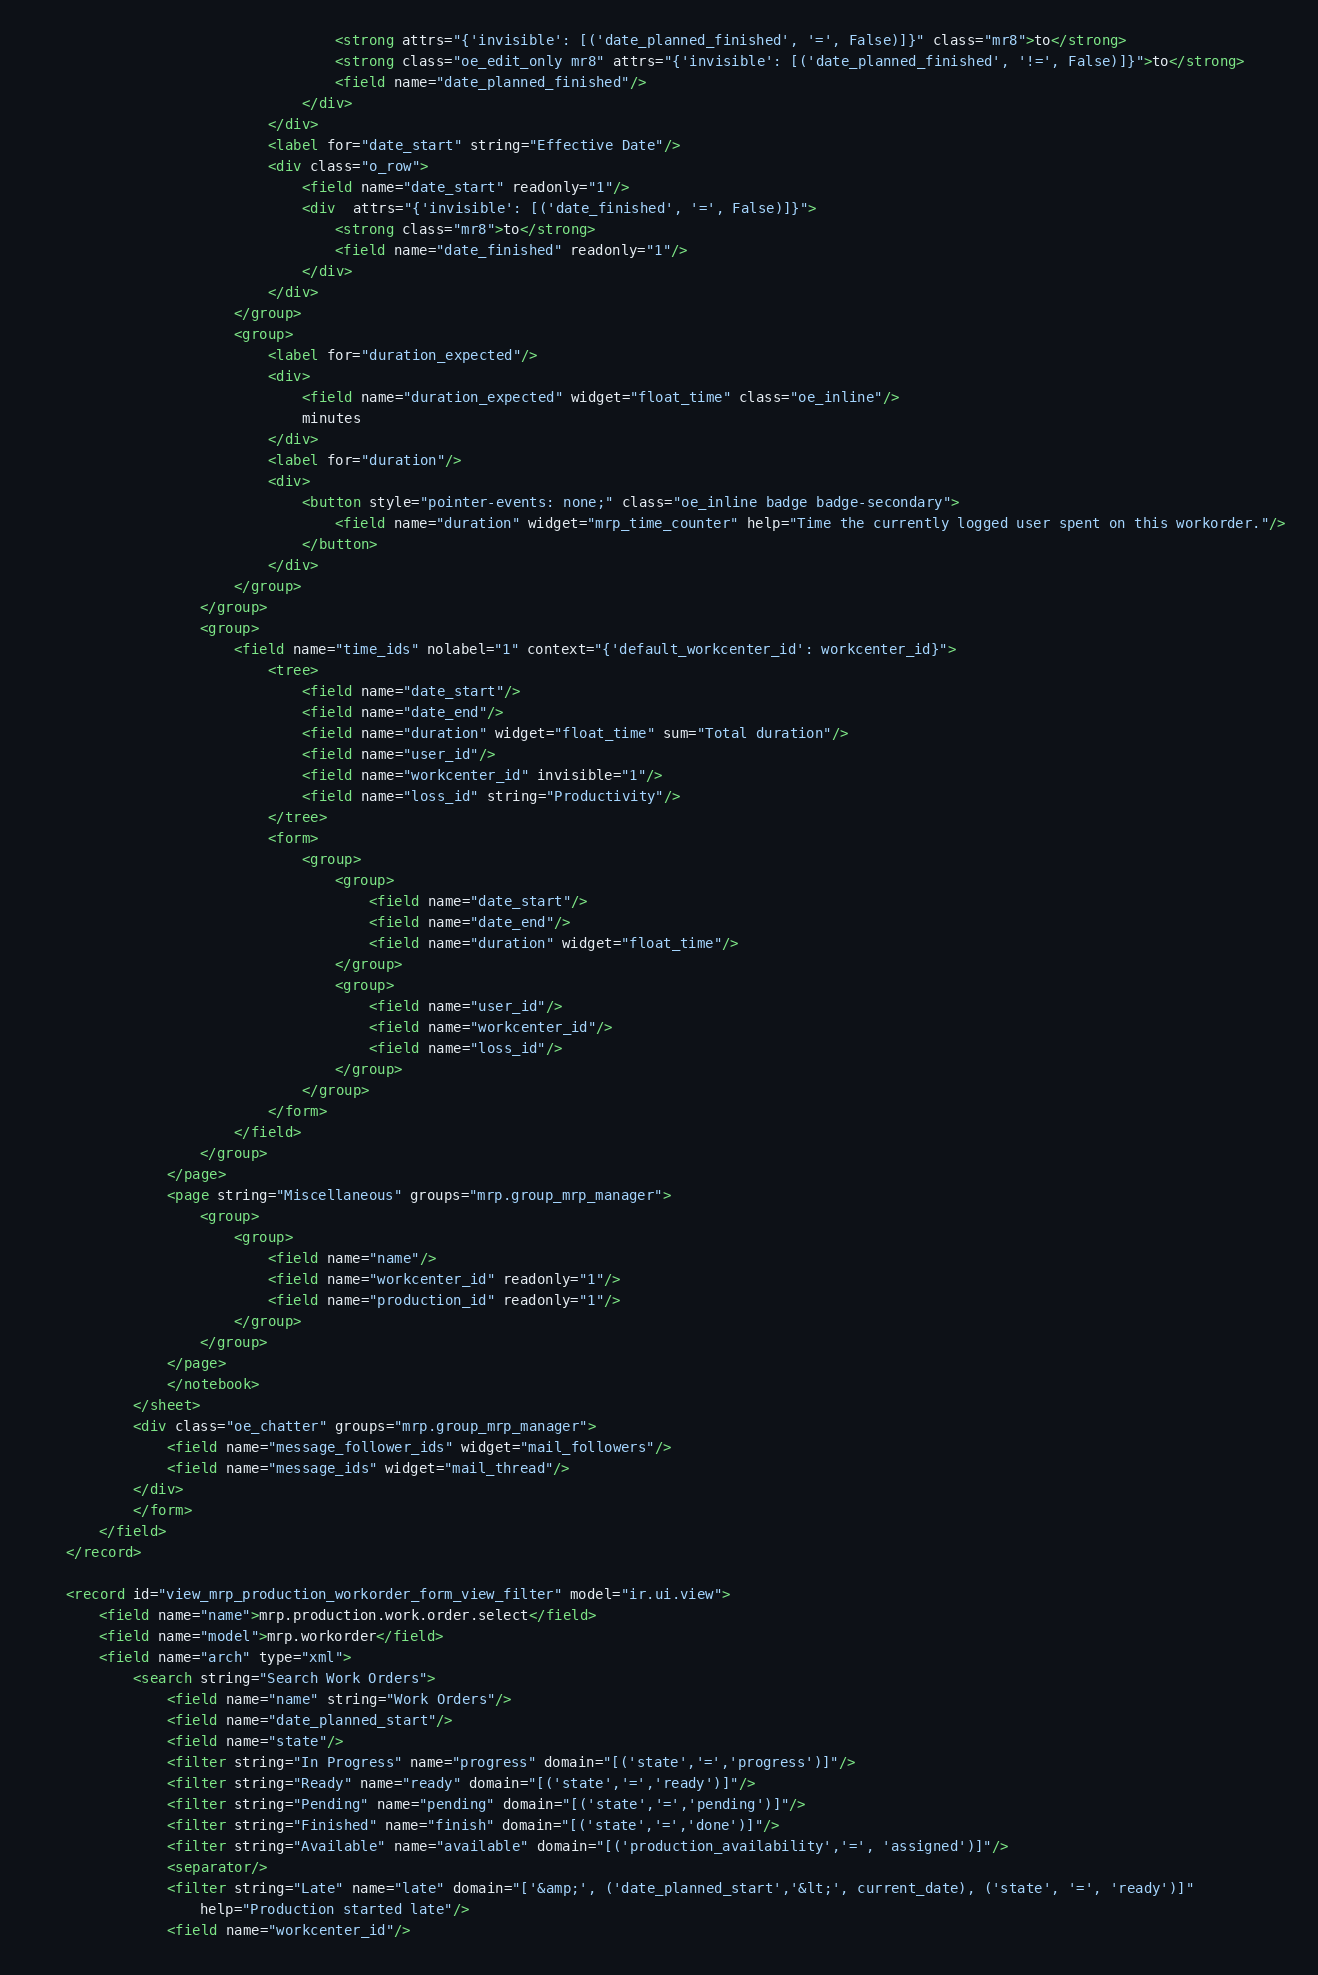<code> <loc_0><loc_0><loc_500><loc_500><_XML_>                                    <strong attrs="{'invisible': [('date_planned_finished', '=', False)]}" class="mr8">to</strong>
                                    <strong class="oe_edit_only mr8" attrs="{'invisible': [('date_planned_finished', '!=', False)]}">to</strong>
                                    <field name="date_planned_finished"/>
                                </div>
                            </div>
                            <label for="date_start" string="Effective Date"/>
                            <div class="o_row">
                                <field name="date_start" readonly="1"/>
                                <div  attrs="{'invisible': [('date_finished', '=', False)]}">
                                    <strong class="mr8">to</strong>
                                    <field name="date_finished" readonly="1"/>
                                </div>
                            </div>
                        </group>
                        <group>
                            <label for="duration_expected"/>
                            <div>
                                <field name="duration_expected" widget="float_time" class="oe_inline"/>
                                minutes
                            </div>
                            <label for="duration"/>
                            <div>
                                <button style="pointer-events: none;" class="oe_inline badge badge-secondary">
                                    <field name="duration" widget="mrp_time_counter" help="Time the currently logged user spent on this workorder."/>
                                </button>
                            </div>
                        </group>
                    </group>
                    <group>
                        <field name="time_ids" nolabel="1" context="{'default_workcenter_id': workcenter_id}">
                            <tree>
                                <field name="date_start"/>
                                <field name="date_end"/>
                                <field name="duration" widget="float_time" sum="Total duration"/>
                                <field name="user_id"/>
                                <field name="workcenter_id" invisible="1"/>
                                <field name="loss_id" string="Productivity"/>
                            </tree>
                            <form>
                                <group>
                                    <group>
                                        <field name="date_start"/>
                                        <field name="date_end"/>
                                        <field name="duration" widget="float_time"/>
                                    </group>
                                    <group>
                                        <field name="user_id"/>
                                        <field name="workcenter_id"/>
                                        <field name="loss_id"/>
                                    </group>
                                </group>
                            </form>
                        </field>
                    </group>
                </page>
                <page string="Miscellaneous" groups="mrp.group_mrp_manager">
                    <group>
                        <group>
                            <field name="name"/>
                            <field name="workcenter_id" readonly="1"/>
                            <field name="production_id" readonly="1"/>
                        </group>
                    </group>
                </page>
                </notebook>
            </sheet>
            <div class="oe_chatter" groups="mrp.group_mrp_manager">
                <field name="message_follower_ids" widget="mail_followers"/>
                <field name="message_ids" widget="mail_thread"/>
            </div>
            </form>
        </field>
    </record>

    <record id="view_mrp_production_workorder_form_view_filter" model="ir.ui.view">
        <field name="name">mrp.production.work.order.select</field>
        <field name="model">mrp.workorder</field>
        <field name="arch" type="xml">
            <search string="Search Work Orders">
                <field name="name" string="Work Orders"/>
                <field name="date_planned_start"/>
                <field name="state"/>
                <filter string="In Progress" name="progress" domain="[('state','=','progress')]"/>
                <filter string="Ready" name="ready" domain="[('state','=','ready')]"/>
                <filter string="Pending" name="pending" domain="[('state','=','pending')]"/>
                <filter string="Finished" name="finish" domain="[('state','=','done')]"/>
                <filter string="Available" name="available" domain="[('production_availability','=', 'assigned')]"/>
                <separator/>
                <filter string="Late" name="late" domain="['&amp;', ('date_planned_start','&lt;', current_date), ('state', '=', 'ready')]"
                    help="Production started late"/>
                <field name="workcenter_id"/></code> 